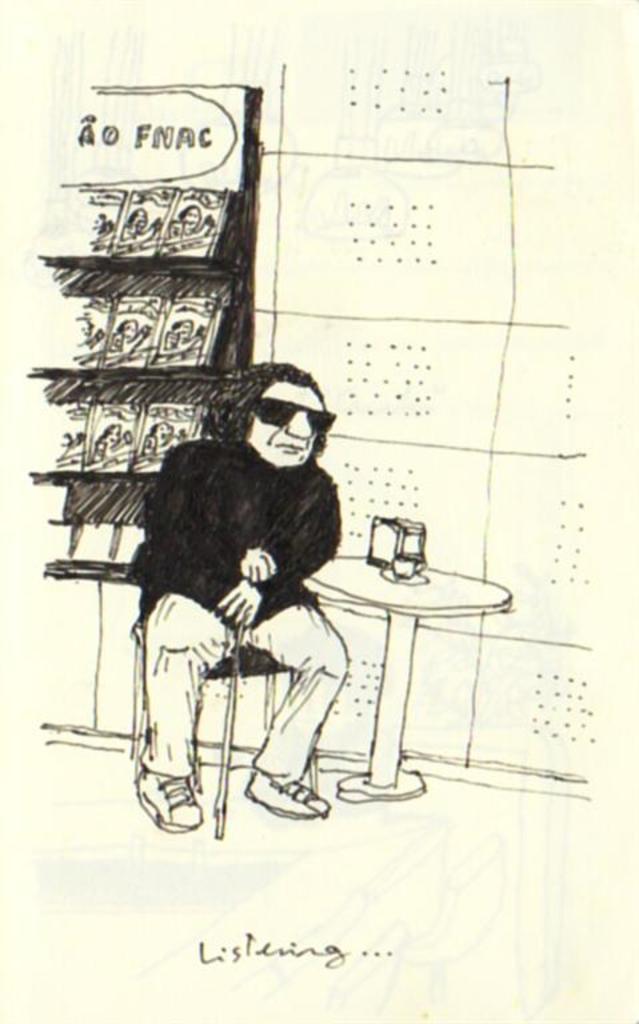How would you summarize this image in a sentence or two? In this image there is a paper. On the paper there is a sketch of a person sat on the chair and holding a stick in his hand, in front of him there is a table with some objects on it, behind him there are books arranged on a rack. 